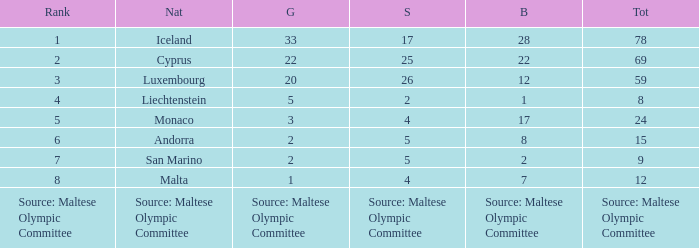How many bronze medals does the nation ranked number 1 have? 28.0. 